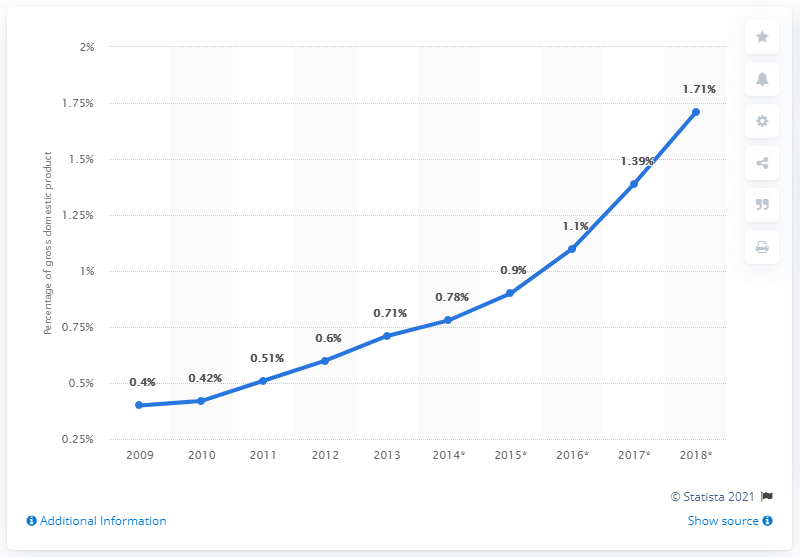Outline some significant characteristics in this image. The ratio of 2009 to 2010 is 0.952380952... The year 2016 had a percent of 1.1%. 